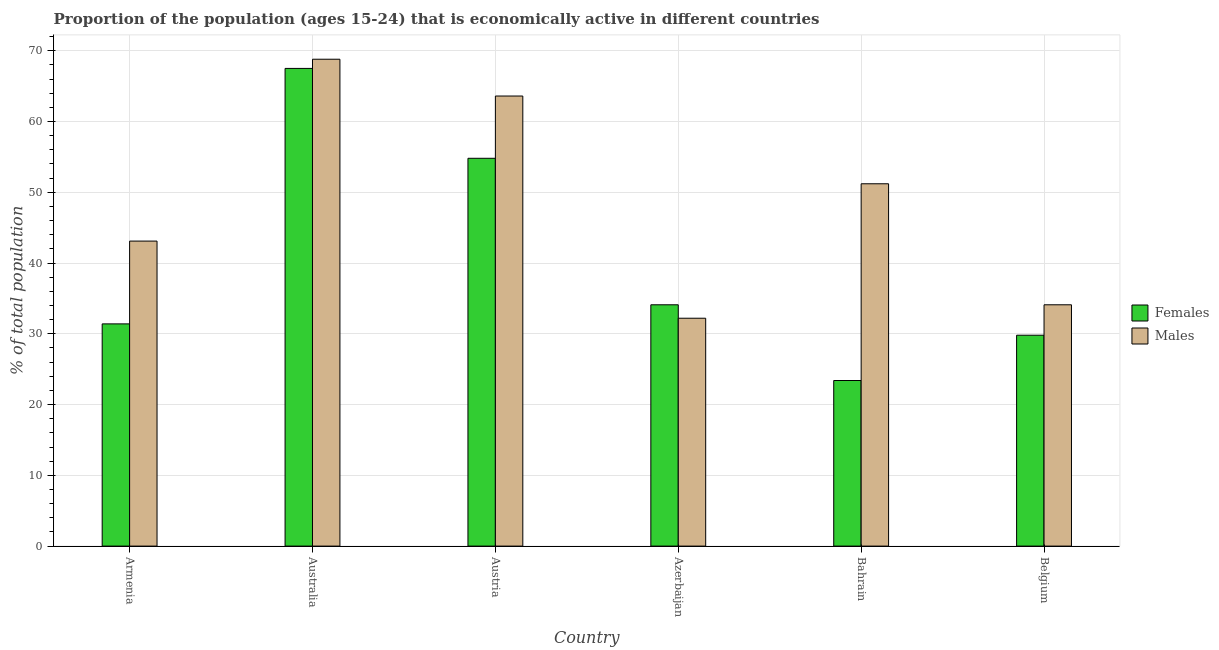Are the number of bars per tick equal to the number of legend labels?
Provide a succinct answer. Yes. Are the number of bars on each tick of the X-axis equal?
Make the answer very short. Yes. How many bars are there on the 6th tick from the left?
Provide a succinct answer. 2. What is the label of the 3rd group of bars from the left?
Give a very brief answer. Austria. In how many cases, is the number of bars for a given country not equal to the number of legend labels?
Ensure brevity in your answer.  0. What is the percentage of economically active male population in Australia?
Provide a succinct answer. 68.8. Across all countries, what is the maximum percentage of economically active male population?
Offer a terse response. 68.8. Across all countries, what is the minimum percentage of economically active female population?
Your answer should be compact. 23.4. In which country was the percentage of economically active male population minimum?
Keep it short and to the point. Azerbaijan. What is the total percentage of economically active female population in the graph?
Provide a short and direct response. 241. What is the difference between the percentage of economically active male population in Australia and that in Belgium?
Provide a short and direct response. 34.7. What is the difference between the percentage of economically active female population in Australia and the percentage of economically active male population in Armenia?
Keep it short and to the point. 24.4. What is the average percentage of economically active female population per country?
Your response must be concise. 40.17. What is the difference between the percentage of economically active male population and percentage of economically active female population in Bahrain?
Provide a succinct answer. 27.8. What is the ratio of the percentage of economically active male population in Bahrain to that in Belgium?
Your answer should be very brief. 1.5. Is the percentage of economically active female population in Azerbaijan less than that in Belgium?
Offer a terse response. No. Is the difference between the percentage of economically active male population in Azerbaijan and Belgium greater than the difference between the percentage of economically active female population in Azerbaijan and Belgium?
Your response must be concise. No. What is the difference between the highest and the second highest percentage of economically active male population?
Your response must be concise. 5.2. What is the difference between the highest and the lowest percentage of economically active male population?
Your answer should be very brief. 36.6. Is the sum of the percentage of economically active male population in Armenia and Austria greater than the maximum percentage of economically active female population across all countries?
Your answer should be compact. Yes. What does the 1st bar from the left in Armenia represents?
Your answer should be compact. Females. What does the 2nd bar from the right in Armenia represents?
Ensure brevity in your answer.  Females. Where does the legend appear in the graph?
Provide a succinct answer. Center right. What is the title of the graph?
Keep it short and to the point. Proportion of the population (ages 15-24) that is economically active in different countries. Does "Broad money growth" appear as one of the legend labels in the graph?
Provide a short and direct response. No. What is the label or title of the Y-axis?
Offer a very short reply. % of total population. What is the % of total population in Females in Armenia?
Your response must be concise. 31.4. What is the % of total population of Males in Armenia?
Offer a terse response. 43.1. What is the % of total population in Females in Australia?
Your response must be concise. 67.5. What is the % of total population in Males in Australia?
Your answer should be compact. 68.8. What is the % of total population of Females in Austria?
Offer a terse response. 54.8. What is the % of total population in Males in Austria?
Provide a short and direct response. 63.6. What is the % of total population in Females in Azerbaijan?
Make the answer very short. 34.1. What is the % of total population in Males in Azerbaijan?
Your response must be concise. 32.2. What is the % of total population of Females in Bahrain?
Your answer should be compact. 23.4. What is the % of total population of Males in Bahrain?
Provide a short and direct response. 51.2. What is the % of total population in Females in Belgium?
Offer a very short reply. 29.8. What is the % of total population in Males in Belgium?
Keep it short and to the point. 34.1. Across all countries, what is the maximum % of total population in Females?
Make the answer very short. 67.5. Across all countries, what is the maximum % of total population of Males?
Offer a very short reply. 68.8. Across all countries, what is the minimum % of total population of Females?
Ensure brevity in your answer.  23.4. Across all countries, what is the minimum % of total population of Males?
Keep it short and to the point. 32.2. What is the total % of total population of Females in the graph?
Offer a terse response. 241. What is the total % of total population in Males in the graph?
Your response must be concise. 293. What is the difference between the % of total population in Females in Armenia and that in Australia?
Provide a succinct answer. -36.1. What is the difference between the % of total population of Males in Armenia and that in Australia?
Provide a succinct answer. -25.7. What is the difference between the % of total population of Females in Armenia and that in Austria?
Offer a terse response. -23.4. What is the difference between the % of total population of Males in Armenia and that in Austria?
Provide a short and direct response. -20.5. What is the difference between the % of total population of Females in Armenia and that in Bahrain?
Your answer should be very brief. 8. What is the difference between the % of total population in Females in Armenia and that in Belgium?
Provide a short and direct response. 1.6. What is the difference between the % of total population of Females in Australia and that in Azerbaijan?
Keep it short and to the point. 33.4. What is the difference between the % of total population in Males in Australia and that in Azerbaijan?
Provide a succinct answer. 36.6. What is the difference between the % of total population of Females in Australia and that in Bahrain?
Offer a terse response. 44.1. What is the difference between the % of total population of Males in Australia and that in Bahrain?
Provide a short and direct response. 17.6. What is the difference between the % of total population in Females in Australia and that in Belgium?
Keep it short and to the point. 37.7. What is the difference between the % of total population of Males in Australia and that in Belgium?
Give a very brief answer. 34.7. What is the difference between the % of total population of Females in Austria and that in Azerbaijan?
Provide a succinct answer. 20.7. What is the difference between the % of total population in Males in Austria and that in Azerbaijan?
Your answer should be compact. 31.4. What is the difference between the % of total population of Females in Austria and that in Bahrain?
Your answer should be compact. 31.4. What is the difference between the % of total population in Males in Austria and that in Belgium?
Your answer should be compact. 29.5. What is the difference between the % of total population in Males in Azerbaijan and that in Bahrain?
Offer a terse response. -19. What is the difference between the % of total population in Males in Azerbaijan and that in Belgium?
Ensure brevity in your answer.  -1.9. What is the difference between the % of total population of Females in Bahrain and that in Belgium?
Ensure brevity in your answer.  -6.4. What is the difference between the % of total population of Females in Armenia and the % of total population of Males in Australia?
Your answer should be compact. -37.4. What is the difference between the % of total population in Females in Armenia and the % of total population in Males in Austria?
Your answer should be very brief. -32.2. What is the difference between the % of total population in Females in Armenia and the % of total population in Males in Bahrain?
Keep it short and to the point. -19.8. What is the difference between the % of total population in Females in Australia and the % of total population in Males in Azerbaijan?
Give a very brief answer. 35.3. What is the difference between the % of total population of Females in Australia and the % of total population of Males in Bahrain?
Provide a short and direct response. 16.3. What is the difference between the % of total population in Females in Australia and the % of total population in Males in Belgium?
Ensure brevity in your answer.  33.4. What is the difference between the % of total population of Females in Austria and the % of total population of Males in Azerbaijan?
Your answer should be very brief. 22.6. What is the difference between the % of total population in Females in Austria and the % of total population in Males in Belgium?
Offer a terse response. 20.7. What is the difference between the % of total population in Females in Azerbaijan and the % of total population in Males in Bahrain?
Your answer should be compact. -17.1. What is the difference between the % of total population of Females in Bahrain and the % of total population of Males in Belgium?
Offer a very short reply. -10.7. What is the average % of total population in Females per country?
Ensure brevity in your answer.  40.17. What is the average % of total population of Males per country?
Your answer should be very brief. 48.83. What is the difference between the % of total population in Females and % of total population in Males in Azerbaijan?
Ensure brevity in your answer.  1.9. What is the difference between the % of total population of Females and % of total population of Males in Bahrain?
Your response must be concise. -27.8. What is the ratio of the % of total population of Females in Armenia to that in Australia?
Make the answer very short. 0.47. What is the ratio of the % of total population of Males in Armenia to that in Australia?
Make the answer very short. 0.63. What is the ratio of the % of total population of Females in Armenia to that in Austria?
Your answer should be compact. 0.57. What is the ratio of the % of total population of Males in Armenia to that in Austria?
Your answer should be compact. 0.68. What is the ratio of the % of total population of Females in Armenia to that in Azerbaijan?
Your response must be concise. 0.92. What is the ratio of the % of total population in Males in Armenia to that in Azerbaijan?
Your answer should be very brief. 1.34. What is the ratio of the % of total population of Females in Armenia to that in Bahrain?
Provide a succinct answer. 1.34. What is the ratio of the % of total population in Males in Armenia to that in Bahrain?
Make the answer very short. 0.84. What is the ratio of the % of total population of Females in Armenia to that in Belgium?
Provide a succinct answer. 1.05. What is the ratio of the % of total population of Males in Armenia to that in Belgium?
Offer a terse response. 1.26. What is the ratio of the % of total population of Females in Australia to that in Austria?
Provide a short and direct response. 1.23. What is the ratio of the % of total population in Males in Australia to that in Austria?
Give a very brief answer. 1.08. What is the ratio of the % of total population of Females in Australia to that in Azerbaijan?
Give a very brief answer. 1.98. What is the ratio of the % of total population of Males in Australia to that in Azerbaijan?
Keep it short and to the point. 2.14. What is the ratio of the % of total population of Females in Australia to that in Bahrain?
Keep it short and to the point. 2.88. What is the ratio of the % of total population in Males in Australia to that in Bahrain?
Your response must be concise. 1.34. What is the ratio of the % of total population of Females in Australia to that in Belgium?
Ensure brevity in your answer.  2.27. What is the ratio of the % of total population of Males in Australia to that in Belgium?
Ensure brevity in your answer.  2.02. What is the ratio of the % of total population of Females in Austria to that in Azerbaijan?
Your answer should be very brief. 1.61. What is the ratio of the % of total population in Males in Austria to that in Azerbaijan?
Give a very brief answer. 1.98. What is the ratio of the % of total population of Females in Austria to that in Bahrain?
Offer a terse response. 2.34. What is the ratio of the % of total population of Males in Austria to that in Bahrain?
Ensure brevity in your answer.  1.24. What is the ratio of the % of total population in Females in Austria to that in Belgium?
Your answer should be compact. 1.84. What is the ratio of the % of total population of Males in Austria to that in Belgium?
Provide a succinct answer. 1.87. What is the ratio of the % of total population in Females in Azerbaijan to that in Bahrain?
Make the answer very short. 1.46. What is the ratio of the % of total population of Males in Azerbaijan to that in Bahrain?
Ensure brevity in your answer.  0.63. What is the ratio of the % of total population of Females in Azerbaijan to that in Belgium?
Give a very brief answer. 1.14. What is the ratio of the % of total population in Males in Azerbaijan to that in Belgium?
Your answer should be compact. 0.94. What is the ratio of the % of total population in Females in Bahrain to that in Belgium?
Your response must be concise. 0.79. What is the ratio of the % of total population of Males in Bahrain to that in Belgium?
Offer a very short reply. 1.5. What is the difference between the highest and the second highest % of total population of Females?
Give a very brief answer. 12.7. What is the difference between the highest and the second highest % of total population in Males?
Ensure brevity in your answer.  5.2. What is the difference between the highest and the lowest % of total population in Females?
Keep it short and to the point. 44.1. What is the difference between the highest and the lowest % of total population of Males?
Make the answer very short. 36.6. 